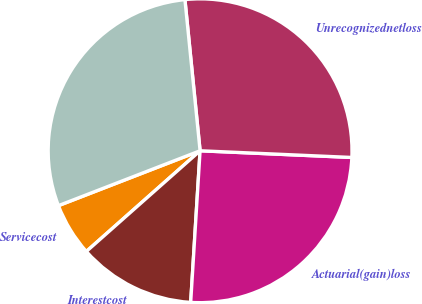<chart> <loc_0><loc_0><loc_500><loc_500><pie_chart><fcel>Servicecost<fcel>Interestcost<fcel>Actuarial(gain)loss<fcel>Unrecognizednetloss<fcel>Unnamed: 4<nl><fcel>5.65%<fcel>12.48%<fcel>25.28%<fcel>27.29%<fcel>29.29%<nl></chart> 